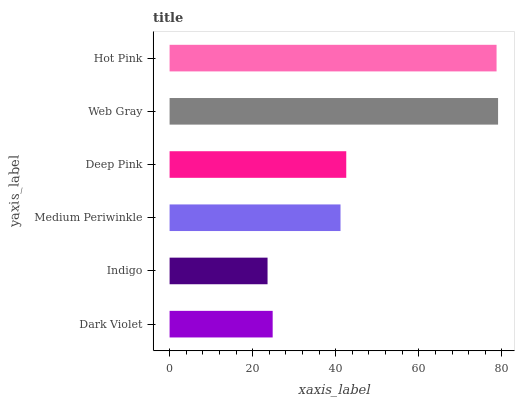Is Indigo the minimum?
Answer yes or no. Yes. Is Web Gray the maximum?
Answer yes or no. Yes. Is Medium Periwinkle the minimum?
Answer yes or no. No. Is Medium Periwinkle the maximum?
Answer yes or no. No. Is Medium Periwinkle greater than Indigo?
Answer yes or no. Yes. Is Indigo less than Medium Periwinkle?
Answer yes or no. Yes. Is Indigo greater than Medium Periwinkle?
Answer yes or no. No. Is Medium Periwinkle less than Indigo?
Answer yes or no. No. Is Deep Pink the high median?
Answer yes or no. Yes. Is Medium Periwinkle the low median?
Answer yes or no. Yes. Is Hot Pink the high median?
Answer yes or no. No. Is Hot Pink the low median?
Answer yes or no. No. 